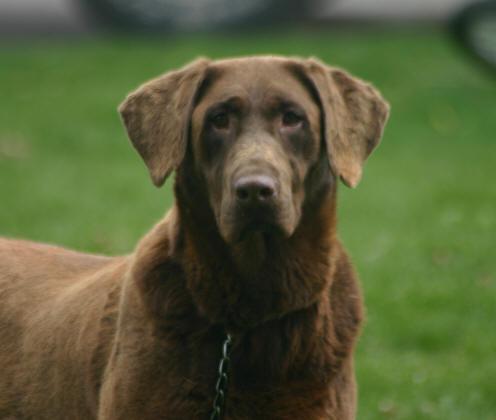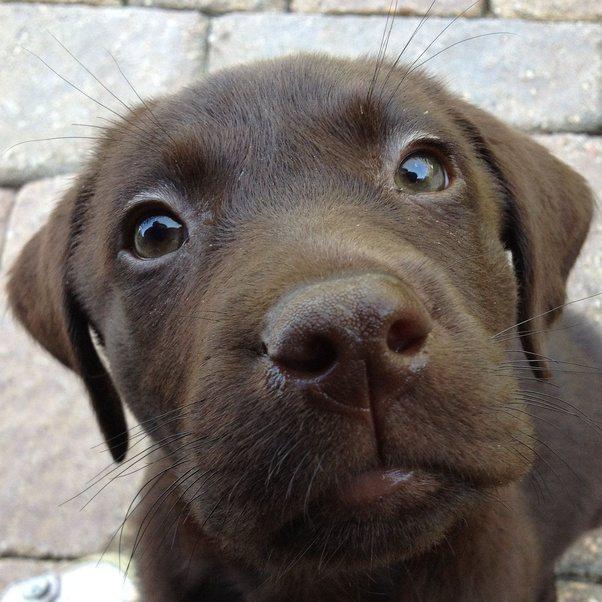The first image is the image on the left, the second image is the image on the right. Considering the images on both sides, is "No grassy ground is visible in one of the dog images." valid? Answer yes or no. Yes. 